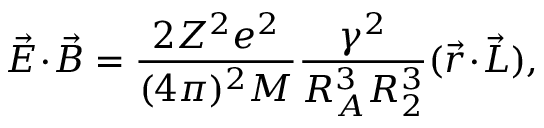<formula> <loc_0><loc_0><loc_500><loc_500>\vec { E } \, \cdot \, \vec { B } = \frac { 2 Z ^ { 2 } e ^ { 2 } } { ( 4 \pi ) ^ { 2 } M } \frac { \gamma ^ { 2 } } { R _ { A } ^ { 3 } R _ { 2 } ^ { 3 } } ( \vec { r } \, \cdot \, \vec { L } ) ,</formula> 